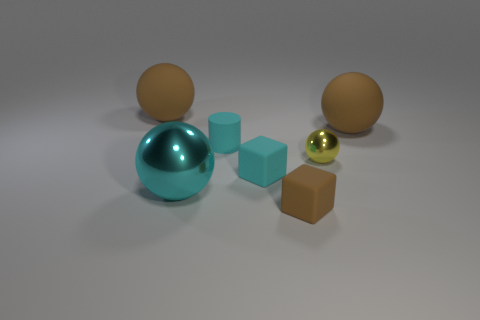How does the composition of the objects in the image suggest their relative weights? The relative sizes and distances between the objects may imply their weights; the larger objects could be perceived as heavier, while the smaller, shinier sphere might be considered lighter due to its small size and reflective material, hinting at a metallic composition. Which of these objects would be the most reflective in a bright room? The small, golden-shiny sphere would be the most reflective object in a bright room. Its polished metallic surface is designed to reflect light much more than the other objects with matte surfaces. 